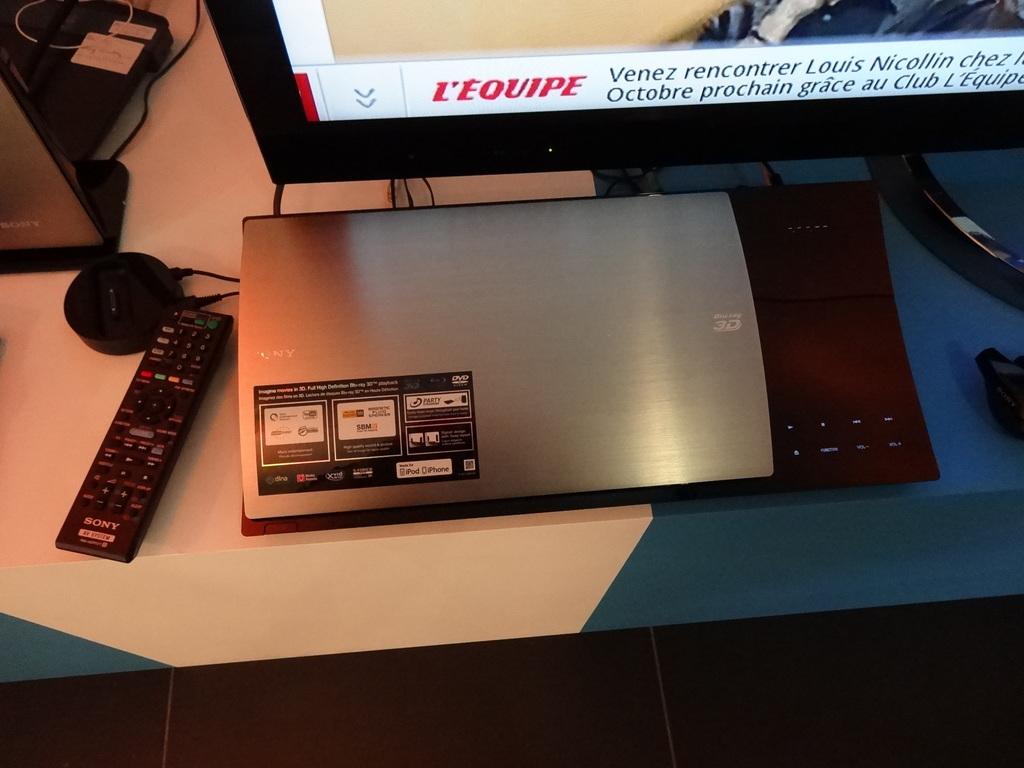What is the brand of remote on the table?
Your answer should be compact. Sony. What red word is on the monitor?
Provide a succinct answer. L'equipe. 